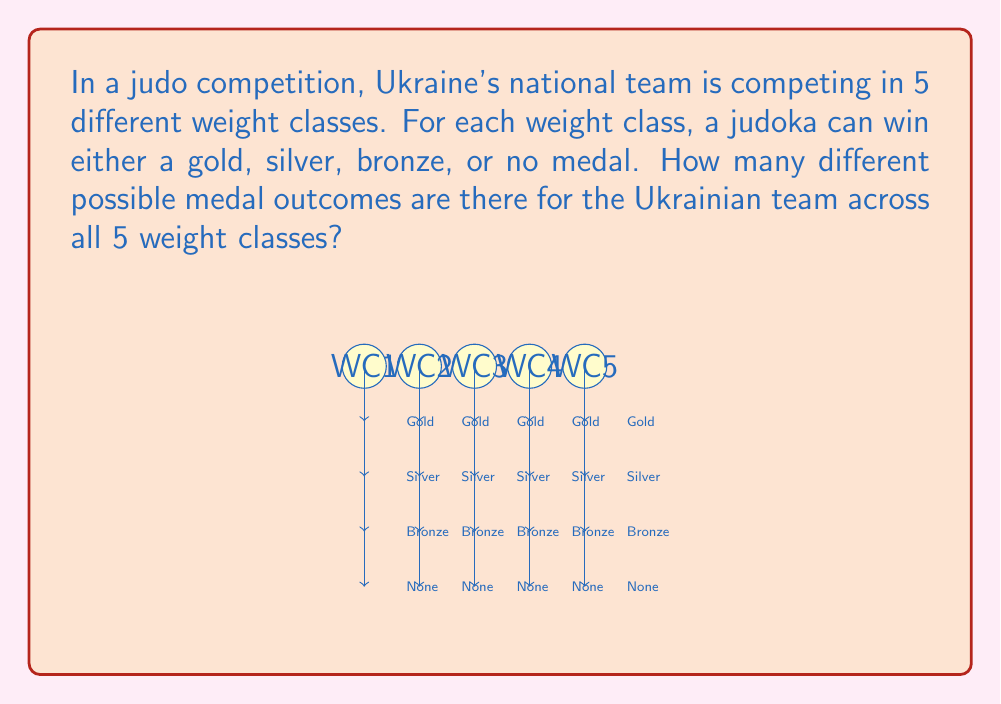Could you help me with this problem? Let's approach this step-by-step:

1) For each weight class, there are 4 possible outcomes:
   - Gold medal
   - Silver medal
   - Bronze medal
   - No medal

2) We need to determine the number of ways these outcomes can occur across all 5 weight classes.

3) This is a case of independent events, where the outcome in one weight class doesn't affect the outcomes in other weight classes.

4) When we have independent events, we multiply the number of possibilities for each event.

5) In this case, we have 4 possibilities for each of the 5 weight classes.

6) Therefore, we can use the multiplication principle:

   $$ \text{Total outcomes} = 4 \times 4 \times 4 \times 4 \times 4 $$

7) This can be written as an exponent:

   $$ \text{Total outcomes} = 4^5 $$

8) Calculating this:

   $$ 4^5 = 4 \times 4 \times 4 \times 4 \times 4 = 1024 $$

Thus, there are 1024 different possible medal outcomes for the Ukrainian judo team across the 5 weight classes.
Answer: $4^5 = 1024$ 